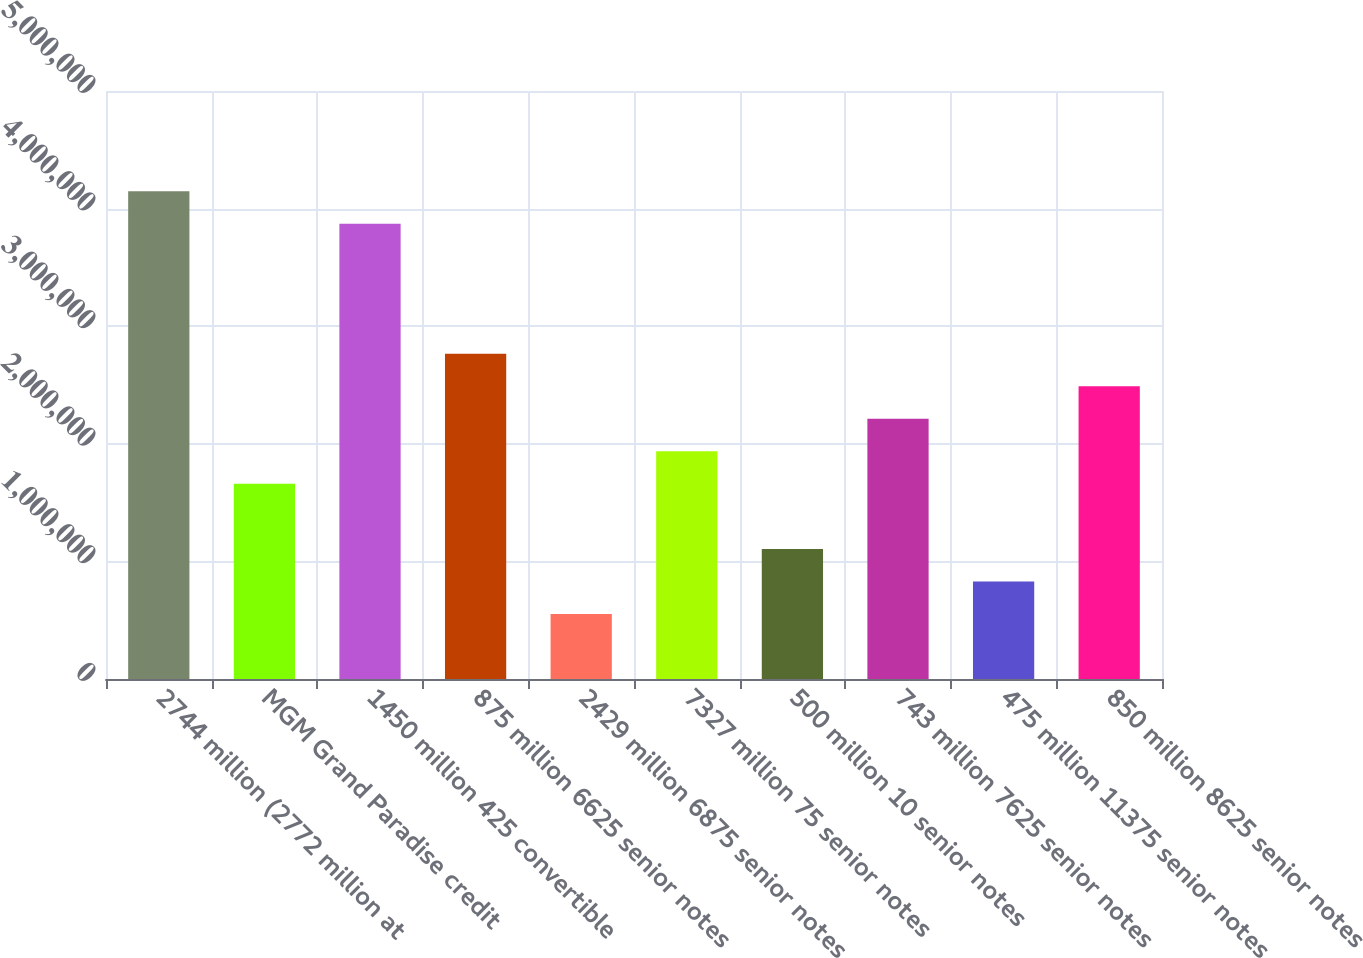Convert chart to OTSL. <chart><loc_0><loc_0><loc_500><loc_500><bar_chart><fcel>2744 million (2772 million at<fcel>MGM Grand Paradise credit<fcel>1450 million 425 convertible<fcel>875 million 6625 senior notes<fcel>2429 million 6875 senior notes<fcel>7327 million 75 senior notes<fcel>500 million 10 senior notes<fcel>743 million 7625 senior notes<fcel>475 million 11375 senior notes<fcel>850 million 8625 senior notes<nl><fcel>4.14728e+06<fcel>1.65925e+06<fcel>3.87083e+06<fcel>2.76504e+06<fcel>553466<fcel>1.9357e+06<fcel>1.10636e+06<fcel>2.21215e+06<fcel>829913<fcel>2.48859e+06<nl></chart> 